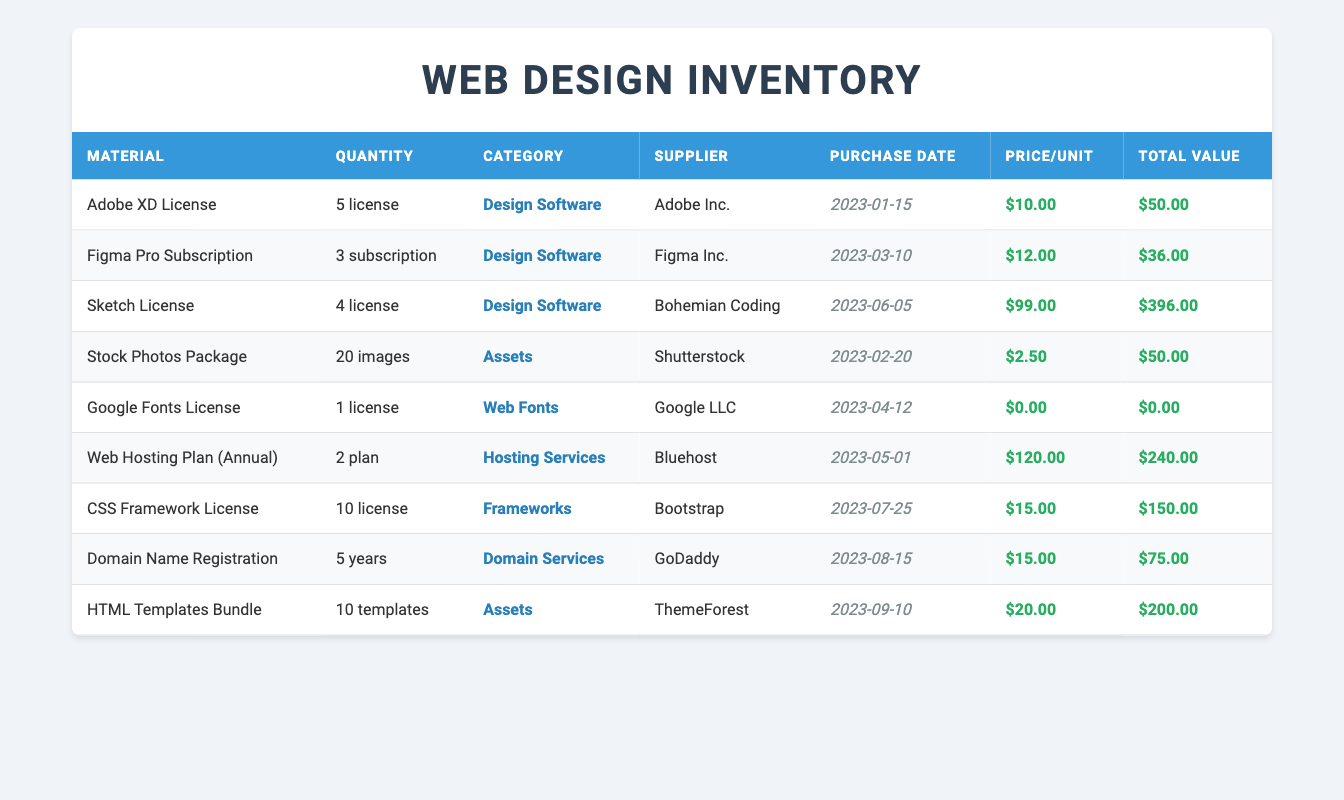What is the total value of all the materials in the inventory? To find the total value, I will add the total values from each row: 50 + 36 + 396 + 50 + 0 + 240 + 150 + 75 + 200 = 997.
Answer: 997 How many licenses of the CSS Framework are available? The table indicates that there are 10 licenses of the CSS Framework available in the inventory.
Answer: 10 licenses Is the Google Fonts License free or paid? The price per unit for the Google Fonts License is $0.00, indicating that it is free.
Answer: Yes, it is free Which supplier provides the most expensive material? Upon reviewing the prices per unit, the Sketch License from Bohemian Coding has the highest price at $99.00 per license.
Answer: Bohemian Coding How much did the materials from the "Design Software" category cost in total? Summing the total values from the materials categorized under "Design Software": 50 (Adobe XD) + 36 (Figma) + 396 (Sketch) = 482.
Answer: 482 What is the average price per unit for the materials in the "Assets" category? The materials in the "Assets" category are Stock Photos Package ($2.50) and HTML Templates Bundle ($20.00). I calculate the average as (2.50 + 20.00) / 2 = 11.25.
Answer: 11.25 Is there a subscription among the materials recorded? Scanning through the table, the Figma Pro Subscription is listed as a subscription-type material.
Answer: Yes, there is a subscription What is the difference in total value between the most and least valuable materials? The most valuable material is the Sketch License at $396.00, and the least is the Google Fonts License at $0.00. The difference is 396 - 0 = 396.
Answer: 396 How many years of domain name registrations were purchased? From the table, it shows there are 5 years of domain name registrations purchased.
Answer: 5 years 